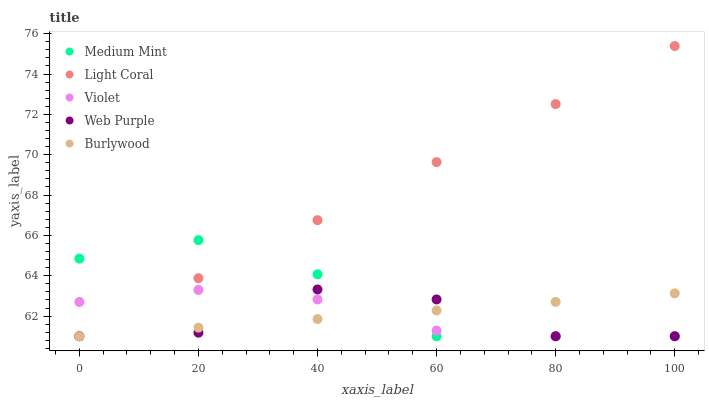Does Web Purple have the minimum area under the curve?
Answer yes or no. Yes. Does Light Coral have the maximum area under the curve?
Answer yes or no. Yes. Does Light Coral have the minimum area under the curve?
Answer yes or no. No. Does Web Purple have the maximum area under the curve?
Answer yes or no. No. Is Burlywood the smoothest?
Answer yes or no. Yes. Is Web Purple the roughest?
Answer yes or no. Yes. Is Light Coral the smoothest?
Answer yes or no. No. Is Light Coral the roughest?
Answer yes or no. No. Does Medium Mint have the lowest value?
Answer yes or no. Yes. Does Light Coral have the highest value?
Answer yes or no. Yes. Does Web Purple have the highest value?
Answer yes or no. No. Does Burlywood intersect Web Purple?
Answer yes or no. Yes. Is Burlywood less than Web Purple?
Answer yes or no. No. Is Burlywood greater than Web Purple?
Answer yes or no. No. 